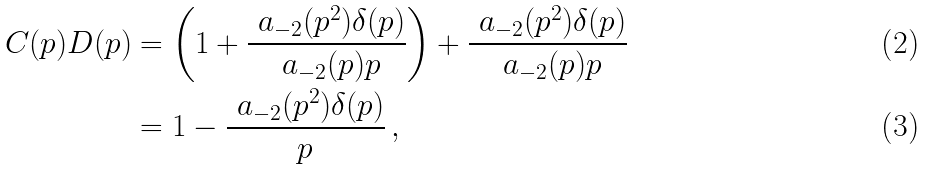<formula> <loc_0><loc_0><loc_500><loc_500>C ( p ) D ( p ) & = \left ( 1 + \frac { \ a _ { - 2 } ( p ^ { 2 } ) \delta ( p ) } { \ a _ { - 2 } ( p ) p } \right ) + \frac { \ a _ { - 2 } ( p ^ { 2 } ) \delta ( p ) } { \ a _ { - 2 } ( p ) p } \\ & = 1 - \frac { \ a _ { - 2 } ( p ^ { 2 } ) \delta ( p ) } { p } \, ,</formula> 